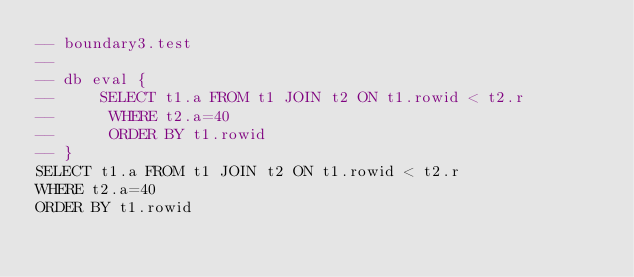<code> <loc_0><loc_0><loc_500><loc_500><_SQL_>-- boundary3.test
-- 
-- db eval {
--     SELECT t1.a FROM t1 JOIN t2 ON t1.rowid < t2.r
--      WHERE t2.a=40
--      ORDER BY t1.rowid
-- }
SELECT t1.a FROM t1 JOIN t2 ON t1.rowid < t2.r
WHERE t2.a=40
ORDER BY t1.rowid</code> 